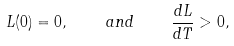Convert formula to latex. <formula><loc_0><loc_0><loc_500><loc_500>L ( 0 ) = 0 , \quad a n d \quad \frac { d L } { d T } > 0 ,</formula> 